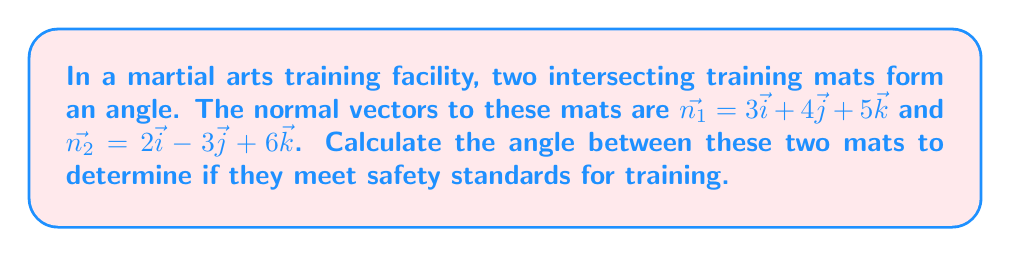Help me with this question. To find the angle between two intersecting planes, we can use the dot product of their normal vectors. The formula for the angle $\theta$ between two planes with normal vectors $\vec{n_1}$ and $\vec{n_2}$ is:

$$\cos \theta = \frac{|\vec{n_1} \cdot \vec{n_2}|}{|\vec{n_1}||\vec{n_2}|}$$

Let's solve this step by step:

1) First, calculate the dot product $\vec{n_1} \cdot \vec{n_2}$:
   $\vec{n_1} \cdot \vec{n_2} = (3)(2) + (4)(-3) + (5)(6) = 6 - 12 + 30 = 24$

2) Calculate the magnitudes of $\vec{n_1}$ and $\vec{n_2}$:
   $|\vec{n_1}| = \sqrt{3^2 + 4^2 + 5^2} = \sqrt{9 + 16 + 25} = \sqrt{50}$
   $|\vec{n_2}| = \sqrt{2^2 + (-3)^2 + 6^2} = \sqrt{4 + 9 + 36} = \sqrt{49} = 7$

3) Now, substitute these values into the formula:
   $$\cos \theta = \frac{|24|}{(\sqrt{50})(7)} = \frac{24}{\sqrt{2450}}$$

4) To find $\theta$, take the inverse cosine (arccos) of both sides:
   $$\theta = \arccos\left(\frac{24}{\sqrt{2450}}\right)$$

5) Using a calculator, we can evaluate this:
   $$\theta \approx 0.9553 \text{ radians}$$

6) Convert to degrees:
   $$\theta \approx 0.9553 \times \frac{180}{\pi} \approx 54.74^\circ$$

[asy]
import geometry;

size(200);
draw((-2,-2)--(2,2), arrow=Arrow(TeXHead));
draw((-2,2)--(2,-2), arrow=Arrow(TeXHead));
draw((0,0)--(1.5,2), arrow=Arrow(TeXHead));
draw((0,0)--(2,-1.5), arrow=Arrow(TeXHead));
label("$\vec{n_1}$", (1.6,2.1), N);
label("$\vec{n_2}$", (2.1,-1.6), E);
label("$\theta$", (0.5,0.3), NE);
[/asy]
Answer: The angle between the two martial arts training mats is approximately $54.74^\circ$. 